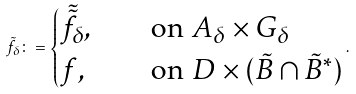Convert formula to latex. <formula><loc_0><loc_0><loc_500><loc_500>\tilde { f } _ { \delta } \colon = \begin{cases} \tilde { \tilde { f } } _ { \delta } , & \quad \text {on} \ A _ { \delta } \times G _ { \delta } \\ f , & \quad \text {on} \ D \times ( \tilde { B } \cap \tilde { B } ^ { \ast } ) \end{cases} .</formula> 